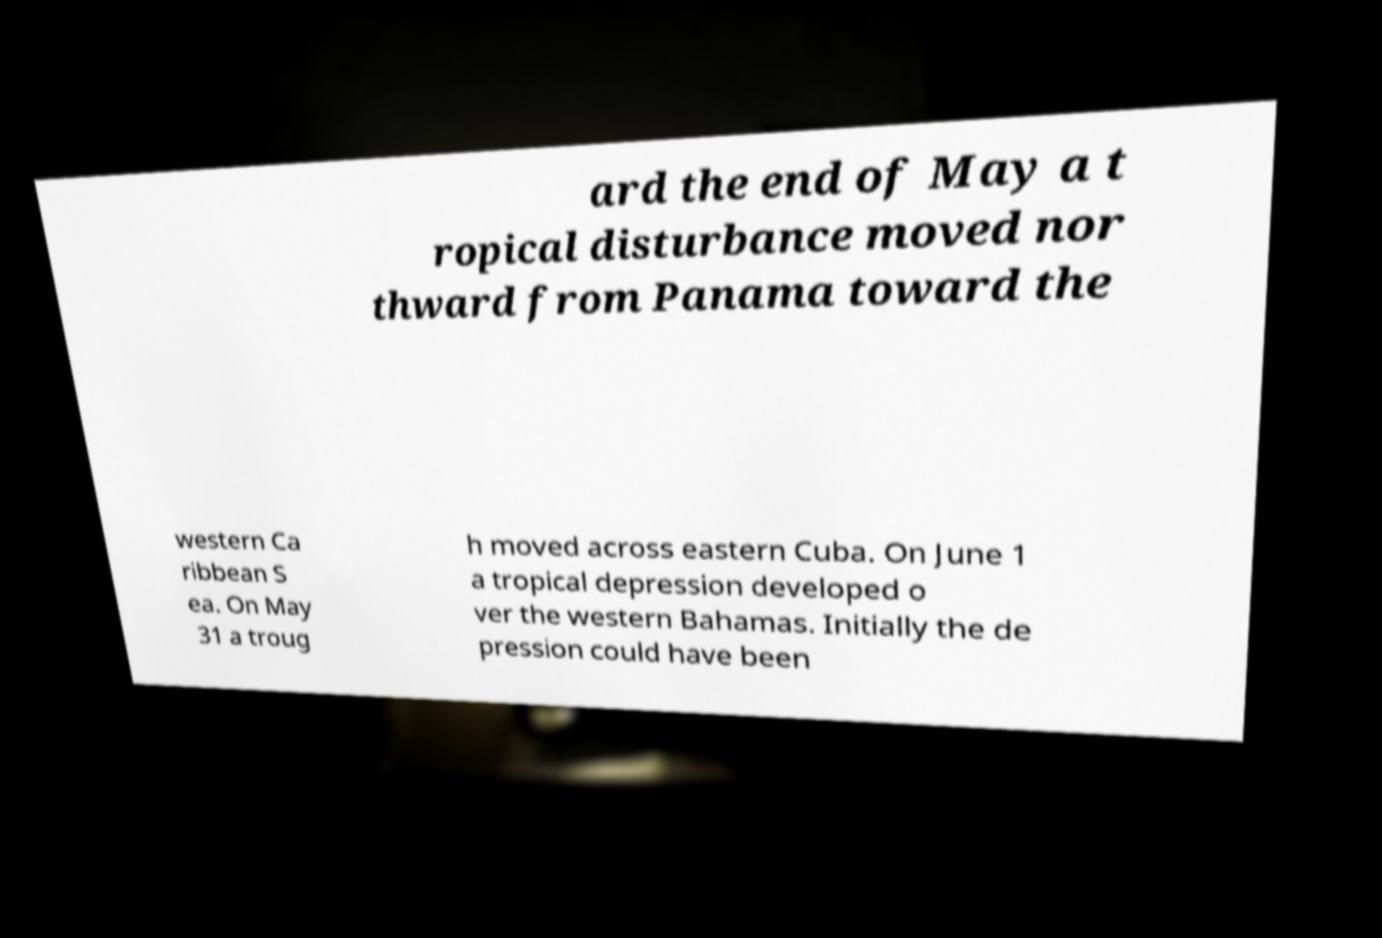For documentation purposes, I need the text within this image transcribed. Could you provide that? ard the end of May a t ropical disturbance moved nor thward from Panama toward the western Ca ribbean S ea. On May 31 a troug h moved across eastern Cuba. On June 1 a tropical depression developed o ver the western Bahamas. Initially the de pression could have been 